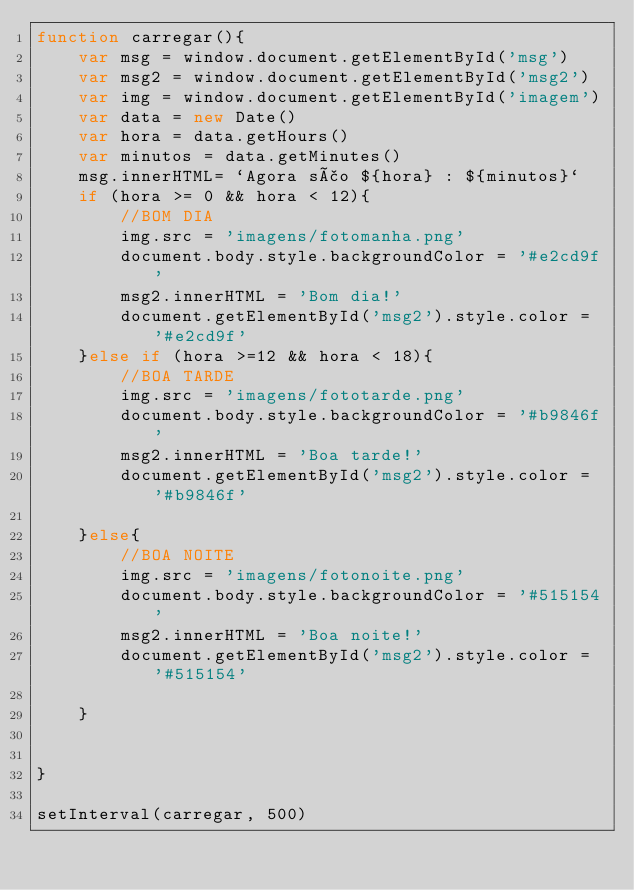<code> <loc_0><loc_0><loc_500><loc_500><_JavaScript_>function carregar(){
    var msg = window.document.getElementById('msg')
    var msg2 = window.document.getElementById('msg2')
    var img = window.document.getElementById('imagem')
    var data = new Date()
    var hora = data.getHours()
    var minutos = data.getMinutes()
    msg.innerHTML= `Agora são ${hora} : ${minutos}`
    if (hora >= 0 && hora < 12){
        //BOM DIA
        img.src = 'imagens/fotomanha.png'
        document.body.style.backgroundColor = '#e2cd9f'
        msg2.innerHTML = 'Bom dia!'
        document.getElementById('msg2').style.color = '#e2cd9f'
    }else if (hora >=12 && hora < 18){
        //BOA TARDE
        img.src = 'imagens/fototarde.png'
        document.body.style.backgroundColor = '#b9846f'
        msg2.innerHTML = 'Boa tarde!'
        document.getElementById('msg2').style.color = '#b9846f'

    }else{
        //BOA NOITE
        img.src = 'imagens/fotonoite.png'
        document.body.style.backgroundColor = '#515154'
        msg2.innerHTML = 'Boa noite!'
        document.getElementById('msg2').style.color = '#515154'

    }


}

setInterval(carregar, 500)

</code> 